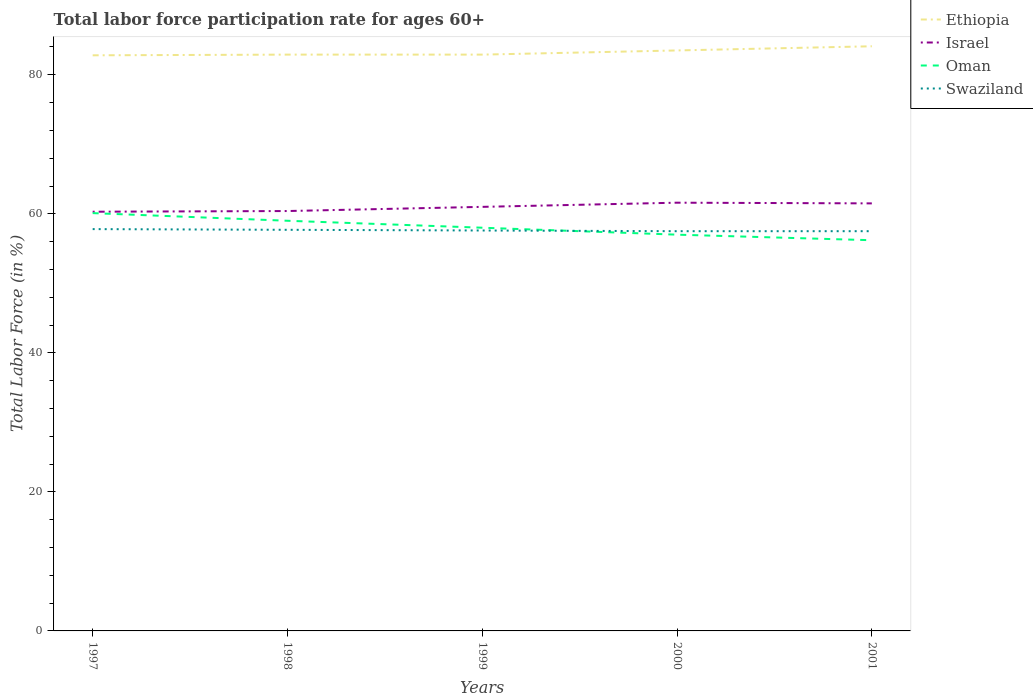How many different coloured lines are there?
Your answer should be very brief. 4. Across all years, what is the maximum labor force participation rate in Israel?
Ensure brevity in your answer.  60.3. What is the total labor force participation rate in Swaziland in the graph?
Make the answer very short. 0.3. What is the difference between the highest and the second highest labor force participation rate in Swaziland?
Your answer should be compact. 0.3. What is the difference between two consecutive major ticks on the Y-axis?
Provide a short and direct response. 20. Does the graph contain grids?
Make the answer very short. No. How many legend labels are there?
Provide a succinct answer. 4. What is the title of the graph?
Give a very brief answer. Total labor force participation rate for ages 60+. What is the label or title of the X-axis?
Provide a short and direct response. Years. What is the Total Labor Force (in %) of Ethiopia in 1997?
Offer a terse response. 82.8. What is the Total Labor Force (in %) of Israel in 1997?
Your answer should be very brief. 60.3. What is the Total Labor Force (in %) of Oman in 1997?
Your response must be concise. 60.1. What is the Total Labor Force (in %) of Swaziland in 1997?
Provide a succinct answer. 57.8. What is the Total Labor Force (in %) of Ethiopia in 1998?
Provide a succinct answer. 82.9. What is the Total Labor Force (in %) of Israel in 1998?
Keep it short and to the point. 60.4. What is the Total Labor Force (in %) in Oman in 1998?
Make the answer very short. 59. What is the Total Labor Force (in %) in Swaziland in 1998?
Ensure brevity in your answer.  57.7. What is the Total Labor Force (in %) in Ethiopia in 1999?
Keep it short and to the point. 82.9. What is the Total Labor Force (in %) of Israel in 1999?
Provide a short and direct response. 61. What is the Total Labor Force (in %) in Oman in 1999?
Your answer should be very brief. 58. What is the Total Labor Force (in %) in Swaziland in 1999?
Your answer should be very brief. 57.6. What is the Total Labor Force (in %) in Ethiopia in 2000?
Your answer should be very brief. 83.5. What is the Total Labor Force (in %) in Israel in 2000?
Offer a terse response. 61.6. What is the Total Labor Force (in %) in Oman in 2000?
Provide a succinct answer. 57. What is the Total Labor Force (in %) in Swaziland in 2000?
Provide a short and direct response. 57.5. What is the Total Labor Force (in %) in Ethiopia in 2001?
Keep it short and to the point. 84.1. What is the Total Labor Force (in %) of Israel in 2001?
Offer a terse response. 61.5. What is the Total Labor Force (in %) in Oman in 2001?
Offer a very short reply. 56.2. What is the Total Labor Force (in %) of Swaziland in 2001?
Your response must be concise. 57.5. Across all years, what is the maximum Total Labor Force (in %) in Ethiopia?
Offer a terse response. 84.1. Across all years, what is the maximum Total Labor Force (in %) in Israel?
Offer a terse response. 61.6. Across all years, what is the maximum Total Labor Force (in %) of Oman?
Provide a short and direct response. 60.1. Across all years, what is the maximum Total Labor Force (in %) of Swaziland?
Your answer should be very brief. 57.8. Across all years, what is the minimum Total Labor Force (in %) in Ethiopia?
Your response must be concise. 82.8. Across all years, what is the minimum Total Labor Force (in %) of Israel?
Ensure brevity in your answer.  60.3. Across all years, what is the minimum Total Labor Force (in %) of Oman?
Provide a short and direct response. 56.2. Across all years, what is the minimum Total Labor Force (in %) in Swaziland?
Keep it short and to the point. 57.5. What is the total Total Labor Force (in %) in Ethiopia in the graph?
Give a very brief answer. 416.2. What is the total Total Labor Force (in %) of Israel in the graph?
Offer a very short reply. 304.8. What is the total Total Labor Force (in %) of Oman in the graph?
Your answer should be compact. 290.3. What is the total Total Labor Force (in %) in Swaziland in the graph?
Your answer should be very brief. 288.1. What is the difference between the Total Labor Force (in %) of Israel in 1997 and that in 1998?
Give a very brief answer. -0.1. What is the difference between the Total Labor Force (in %) in Oman in 1997 and that in 1998?
Provide a short and direct response. 1.1. What is the difference between the Total Labor Force (in %) of Ethiopia in 1997 and that in 1999?
Your response must be concise. -0.1. What is the difference between the Total Labor Force (in %) of Oman in 1997 and that in 1999?
Provide a short and direct response. 2.1. What is the difference between the Total Labor Force (in %) of Swaziland in 1997 and that in 1999?
Provide a succinct answer. 0.2. What is the difference between the Total Labor Force (in %) in Israel in 1997 and that in 2000?
Offer a very short reply. -1.3. What is the difference between the Total Labor Force (in %) in Oman in 1997 and that in 2000?
Ensure brevity in your answer.  3.1. What is the difference between the Total Labor Force (in %) in Ethiopia in 1997 and that in 2001?
Ensure brevity in your answer.  -1.3. What is the difference between the Total Labor Force (in %) in Ethiopia in 1998 and that in 1999?
Your response must be concise. 0. What is the difference between the Total Labor Force (in %) of Swaziland in 1998 and that in 1999?
Offer a terse response. 0.1. What is the difference between the Total Labor Force (in %) of Ethiopia in 1998 and that in 2001?
Your answer should be very brief. -1.2. What is the difference between the Total Labor Force (in %) of Oman in 1999 and that in 2000?
Your answer should be compact. 1. What is the difference between the Total Labor Force (in %) of Oman in 1999 and that in 2001?
Your answer should be compact. 1.8. What is the difference between the Total Labor Force (in %) of Ethiopia in 2000 and that in 2001?
Make the answer very short. -0.6. What is the difference between the Total Labor Force (in %) in Israel in 2000 and that in 2001?
Ensure brevity in your answer.  0.1. What is the difference between the Total Labor Force (in %) in Oman in 2000 and that in 2001?
Ensure brevity in your answer.  0.8. What is the difference between the Total Labor Force (in %) of Ethiopia in 1997 and the Total Labor Force (in %) of Israel in 1998?
Provide a short and direct response. 22.4. What is the difference between the Total Labor Force (in %) in Ethiopia in 1997 and the Total Labor Force (in %) in Oman in 1998?
Ensure brevity in your answer.  23.8. What is the difference between the Total Labor Force (in %) in Ethiopia in 1997 and the Total Labor Force (in %) in Swaziland in 1998?
Provide a succinct answer. 25.1. What is the difference between the Total Labor Force (in %) of Israel in 1997 and the Total Labor Force (in %) of Oman in 1998?
Ensure brevity in your answer.  1.3. What is the difference between the Total Labor Force (in %) of Oman in 1997 and the Total Labor Force (in %) of Swaziland in 1998?
Keep it short and to the point. 2.4. What is the difference between the Total Labor Force (in %) in Ethiopia in 1997 and the Total Labor Force (in %) in Israel in 1999?
Ensure brevity in your answer.  21.8. What is the difference between the Total Labor Force (in %) in Ethiopia in 1997 and the Total Labor Force (in %) in Oman in 1999?
Ensure brevity in your answer.  24.8. What is the difference between the Total Labor Force (in %) of Ethiopia in 1997 and the Total Labor Force (in %) of Swaziland in 1999?
Offer a very short reply. 25.2. What is the difference between the Total Labor Force (in %) of Israel in 1997 and the Total Labor Force (in %) of Oman in 1999?
Provide a short and direct response. 2.3. What is the difference between the Total Labor Force (in %) of Israel in 1997 and the Total Labor Force (in %) of Swaziland in 1999?
Give a very brief answer. 2.7. What is the difference between the Total Labor Force (in %) of Ethiopia in 1997 and the Total Labor Force (in %) of Israel in 2000?
Your answer should be compact. 21.2. What is the difference between the Total Labor Force (in %) in Ethiopia in 1997 and the Total Labor Force (in %) in Oman in 2000?
Your answer should be compact. 25.8. What is the difference between the Total Labor Force (in %) in Ethiopia in 1997 and the Total Labor Force (in %) in Swaziland in 2000?
Your answer should be very brief. 25.3. What is the difference between the Total Labor Force (in %) of Israel in 1997 and the Total Labor Force (in %) of Oman in 2000?
Offer a terse response. 3.3. What is the difference between the Total Labor Force (in %) in Ethiopia in 1997 and the Total Labor Force (in %) in Israel in 2001?
Keep it short and to the point. 21.3. What is the difference between the Total Labor Force (in %) in Ethiopia in 1997 and the Total Labor Force (in %) in Oman in 2001?
Offer a very short reply. 26.6. What is the difference between the Total Labor Force (in %) of Ethiopia in 1997 and the Total Labor Force (in %) of Swaziland in 2001?
Provide a succinct answer. 25.3. What is the difference between the Total Labor Force (in %) of Israel in 1997 and the Total Labor Force (in %) of Oman in 2001?
Make the answer very short. 4.1. What is the difference between the Total Labor Force (in %) of Ethiopia in 1998 and the Total Labor Force (in %) of Israel in 1999?
Provide a short and direct response. 21.9. What is the difference between the Total Labor Force (in %) in Ethiopia in 1998 and the Total Labor Force (in %) in Oman in 1999?
Keep it short and to the point. 24.9. What is the difference between the Total Labor Force (in %) of Ethiopia in 1998 and the Total Labor Force (in %) of Swaziland in 1999?
Offer a very short reply. 25.3. What is the difference between the Total Labor Force (in %) of Israel in 1998 and the Total Labor Force (in %) of Swaziland in 1999?
Provide a short and direct response. 2.8. What is the difference between the Total Labor Force (in %) in Ethiopia in 1998 and the Total Labor Force (in %) in Israel in 2000?
Your answer should be compact. 21.3. What is the difference between the Total Labor Force (in %) of Ethiopia in 1998 and the Total Labor Force (in %) of Oman in 2000?
Offer a terse response. 25.9. What is the difference between the Total Labor Force (in %) in Ethiopia in 1998 and the Total Labor Force (in %) in Swaziland in 2000?
Ensure brevity in your answer.  25.4. What is the difference between the Total Labor Force (in %) of Israel in 1998 and the Total Labor Force (in %) of Oman in 2000?
Offer a very short reply. 3.4. What is the difference between the Total Labor Force (in %) of Oman in 1998 and the Total Labor Force (in %) of Swaziland in 2000?
Your response must be concise. 1.5. What is the difference between the Total Labor Force (in %) in Ethiopia in 1998 and the Total Labor Force (in %) in Israel in 2001?
Keep it short and to the point. 21.4. What is the difference between the Total Labor Force (in %) of Ethiopia in 1998 and the Total Labor Force (in %) of Oman in 2001?
Your response must be concise. 26.7. What is the difference between the Total Labor Force (in %) of Ethiopia in 1998 and the Total Labor Force (in %) of Swaziland in 2001?
Keep it short and to the point. 25.4. What is the difference between the Total Labor Force (in %) of Israel in 1998 and the Total Labor Force (in %) of Oman in 2001?
Provide a short and direct response. 4.2. What is the difference between the Total Labor Force (in %) in Israel in 1998 and the Total Labor Force (in %) in Swaziland in 2001?
Keep it short and to the point. 2.9. What is the difference between the Total Labor Force (in %) of Ethiopia in 1999 and the Total Labor Force (in %) of Israel in 2000?
Offer a very short reply. 21.3. What is the difference between the Total Labor Force (in %) in Ethiopia in 1999 and the Total Labor Force (in %) in Oman in 2000?
Keep it short and to the point. 25.9. What is the difference between the Total Labor Force (in %) in Ethiopia in 1999 and the Total Labor Force (in %) in Swaziland in 2000?
Provide a short and direct response. 25.4. What is the difference between the Total Labor Force (in %) in Israel in 1999 and the Total Labor Force (in %) in Oman in 2000?
Give a very brief answer. 4. What is the difference between the Total Labor Force (in %) in Ethiopia in 1999 and the Total Labor Force (in %) in Israel in 2001?
Your answer should be compact. 21.4. What is the difference between the Total Labor Force (in %) in Ethiopia in 1999 and the Total Labor Force (in %) in Oman in 2001?
Your answer should be compact. 26.7. What is the difference between the Total Labor Force (in %) in Ethiopia in 1999 and the Total Labor Force (in %) in Swaziland in 2001?
Ensure brevity in your answer.  25.4. What is the difference between the Total Labor Force (in %) of Israel in 1999 and the Total Labor Force (in %) of Oman in 2001?
Offer a terse response. 4.8. What is the difference between the Total Labor Force (in %) of Oman in 1999 and the Total Labor Force (in %) of Swaziland in 2001?
Provide a short and direct response. 0.5. What is the difference between the Total Labor Force (in %) of Ethiopia in 2000 and the Total Labor Force (in %) of Israel in 2001?
Your response must be concise. 22. What is the difference between the Total Labor Force (in %) in Ethiopia in 2000 and the Total Labor Force (in %) in Oman in 2001?
Your response must be concise. 27.3. What is the difference between the Total Labor Force (in %) of Israel in 2000 and the Total Labor Force (in %) of Swaziland in 2001?
Provide a short and direct response. 4.1. What is the difference between the Total Labor Force (in %) of Oman in 2000 and the Total Labor Force (in %) of Swaziland in 2001?
Your response must be concise. -0.5. What is the average Total Labor Force (in %) of Ethiopia per year?
Keep it short and to the point. 83.24. What is the average Total Labor Force (in %) of Israel per year?
Ensure brevity in your answer.  60.96. What is the average Total Labor Force (in %) of Oman per year?
Keep it short and to the point. 58.06. What is the average Total Labor Force (in %) in Swaziland per year?
Ensure brevity in your answer.  57.62. In the year 1997, what is the difference between the Total Labor Force (in %) of Ethiopia and Total Labor Force (in %) of Oman?
Your answer should be compact. 22.7. In the year 1997, what is the difference between the Total Labor Force (in %) in Israel and Total Labor Force (in %) in Oman?
Your answer should be compact. 0.2. In the year 1998, what is the difference between the Total Labor Force (in %) of Ethiopia and Total Labor Force (in %) of Oman?
Keep it short and to the point. 23.9. In the year 1998, what is the difference between the Total Labor Force (in %) of Ethiopia and Total Labor Force (in %) of Swaziland?
Your answer should be compact. 25.2. In the year 1998, what is the difference between the Total Labor Force (in %) of Israel and Total Labor Force (in %) of Oman?
Keep it short and to the point. 1.4. In the year 1998, what is the difference between the Total Labor Force (in %) of Oman and Total Labor Force (in %) of Swaziland?
Your answer should be very brief. 1.3. In the year 1999, what is the difference between the Total Labor Force (in %) of Ethiopia and Total Labor Force (in %) of Israel?
Keep it short and to the point. 21.9. In the year 1999, what is the difference between the Total Labor Force (in %) of Ethiopia and Total Labor Force (in %) of Oman?
Give a very brief answer. 24.9. In the year 1999, what is the difference between the Total Labor Force (in %) of Ethiopia and Total Labor Force (in %) of Swaziland?
Keep it short and to the point. 25.3. In the year 1999, what is the difference between the Total Labor Force (in %) of Israel and Total Labor Force (in %) of Oman?
Make the answer very short. 3. In the year 1999, what is the difference between the Total Labor Force (in %) in Israel and Total Labor Force (in %) in Swaziland?
Your response must be concise. 3.4. In the year 2000, what is the difference between the Total Labor Force (in %) of Ethiopia and Total Labor Force (in %) of Israel?
Offer a very short reply. 21.9. In the year 2000, what is the difference between the Total Labor Force (in %) in Ethiopia and Total Labor Force (in %) in Swaziland?
Make the answer very short. 26. In the year 2000, what is the difference between the Total Labor Force (in %) of Oman and Total Labor Force (in %) of Swaziland?
Give a very brief answer. -0.5. In the year 2001, what is the difference between the Total Labor Force (in %) in Ethiopia and Total Labor Force (in %) in Israel?
Your answer should be very brief. 22.6. In the year 2001, what is the difference between the Total Labor Force (in %) in Ethiopia and Total Labor Force (in %) in Oman?
Ensure brevity in your answer.  27.9. In the year 2001, what is the difference between the Total Labor Force (in %) in Ethiopia and Total Labor Force (in %) in Swaziland?
Your answer should be very brief. 26.6. In the year 2001, what is the difference between the Total Labor Force (in %) in Israel and Total Labor Force (in %) in Oman?
Keep it short and to the point. 5.3. In the year 2001, what is the difference between the Total Labor Force (in %) of Israel and Total Labor Force (in %) of Swaziland?
Ensure brevity in your answer.  4. In the year 2001, what is the difference between the Total Labor Force (in %) of Oman and Total Labor Force (in %) of Swaziland?
Offer a terse response. -1.3. What is the ratio of the Total Labor Force (in %) of Oman in 1997 to that in 1998?
Ensure brevity in your answer.  1.02. What is the ratio of the Total Labor Force (in %) of Israel in 1997 to that in 1999?
Your response must be concise. 0.99. What is the ratio of the Total Labor Force (in %) of Oman in 1997 to that in 1999?
Your answer should be compact. 1.04. What is the ratio of the Total Labor Force (in %) of Swaziland in 1997 to that in 1999?
Keep it short and to the point. 1. What is the ratio of the Total Labor Force (in %) of Ethiopia in 1997 to that in 2000?
Keep it short and to the point. 0.99. What is the ratio of the Total Labor Force (in %) of Israel in 1997 to that in 2000?
Make the answer very short. 0.98. What is the ratio of the Total Labor Force (in %) of Oman in 1997 to that in 2000?
Provide a succinct answer. 1.05. What is the ratio of the Total Labor Force (in %) of Ethiopia in 1997 to that in 2001?
Provide a succinct answer. 0.98. What is the ratio of the Total Labor Force (in %) in Israel in 1997 to that in 2001?
Give a very brief answer. 0.98. What is the ratio of the Total Labor Force (in %) in Oman in 1997 to that in 2001?
Ensure brevity in your answer.  1.07. What is the ratio of the Total Labor Force (in %) in Israel in 1998 to that in 1999?
Keep it short and to the point. 0.99. What is the ratio of the Total Labor Force (in %) in Oman in 1998 to that in 1999?
Make the answer very short. 1.02. What is the ratio of the Total Labor Force (in %) in Swaziland in 1998 to that in 1999?
Your response must be concise. 1. What is the ratio of the Total Labor Force (in %) of Israel in 1998 to that in 2000?
Make the answer very short. 0.98. What is the ratio of the Total Labor Force (in %) of Oman in 1998 to that in 2000?
Keep it short and to the point. 1.04. What is the ratio of the Total Labor Force (in %) of Swaziland in 1998 to that in 2000?
Provide a succinct answer. 1. What is the ratio of the Total Labor Force (in %) of Ethiopia in 1998 to that in 2001?
Your answer should be very brief. 0.99. What is the ratio of the Total Labor Force (in %) of Israel in 1998 to that in 2001?
Offer a terse response. 0.98. What is the ratio of the Total Labor Force (in %) in Oman in 1998 to that in 2001?
Give a very brief answer. 1.05. What is the ratio of the Total Labor Force (in %) of Ethiopia in 1999 to that in 2000?
Make the answer very short. 0.99. What is the ratio of the Total Labor Force (in %) of Israel in 1999 to that in 2000?
Provide a short and direct response. 0.99. What is the ratio of the Total Labor Force (in %) in Oman in 1999 to that in 2000?
Keep it short and to the point. 1.02. What is the ratio of the Total Labor Force (in %) in Swaziland in 1999 to that in 2000?
Your answer should be compact. 1. What is the ratio of the Total Labor Force (in %) in Ethiopia in 1999 to that in 2001?
Your answer should be very brief. 0.99. What is the ratio of the Total Labor Force (in %) in Oman in 1999 to that in 2001?
Offer a very short reply. 1.03. What is the ratio of the Total Labor Force (in %) in Swaziland in 1999 to that in 2001?
Provide a short and direct response. 1. What is the ratio of the Total Labor Force (in %) in Oman in 2000 to that in 2001?
Provide a succinct answer. 1.01. What is the ratio of the Total Labor Force (in %) of Swaziland in 2000 to that in 2001?
Ensure brevity in your answer.  1. What is the difference between the highest and the second highest Total Labor Force (in %) of Ethiopia?
Provide a succinct answer. 0.6. What is the difference between the highest and the lowest Total Labor Force (in %) in Oman?
Provide a succinct answer. 3.9. What is the difference between the highest and the lowest Total Labor Force (in %) in Swaziland?
Your answer should be compact. 0.3. 